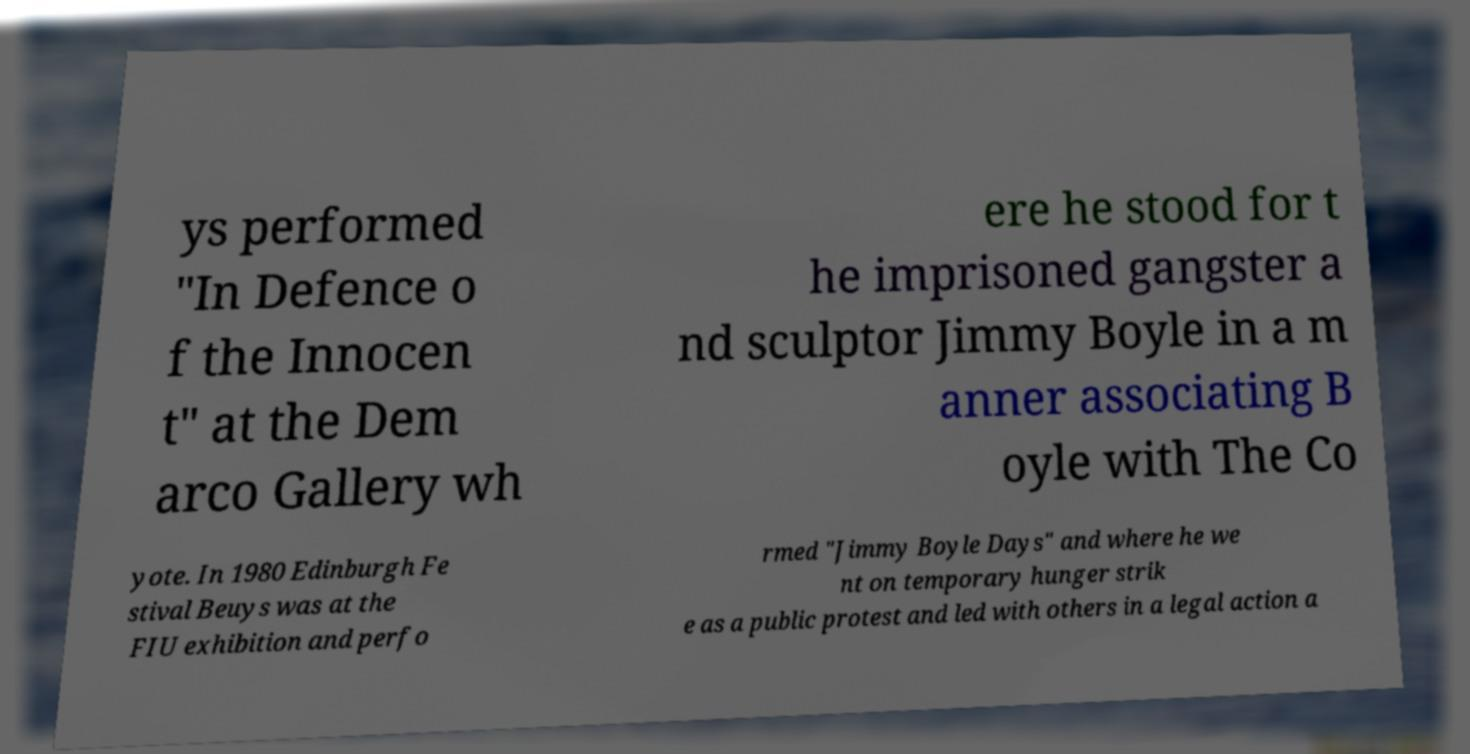Can you read and provide the text displayed in the image?This photo seems to have some interesting text. Can you extract and type it out for me? ys performed "In Defence o f the Innocen t" at the Dem arco Gallery wh ere he stood for t he imprisoned gangster a nd sculptor Jimmy Boyle in a m anner associating B oyle with The Co yote. In 1980 Edinburgh Fe stival Beuys was at the FIU exhibition and perfo rmed "Jimmy Boyle Days" and where he we nt on temporary hunger strik e as a public protest and led with others in a legal action a 